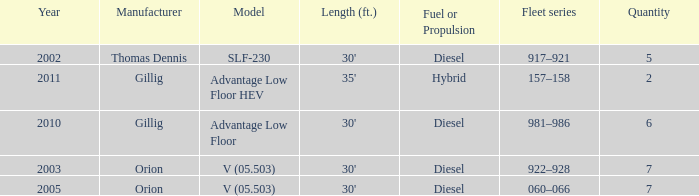Name the sum of quantity for before 2011 model slf-230 5.0. 